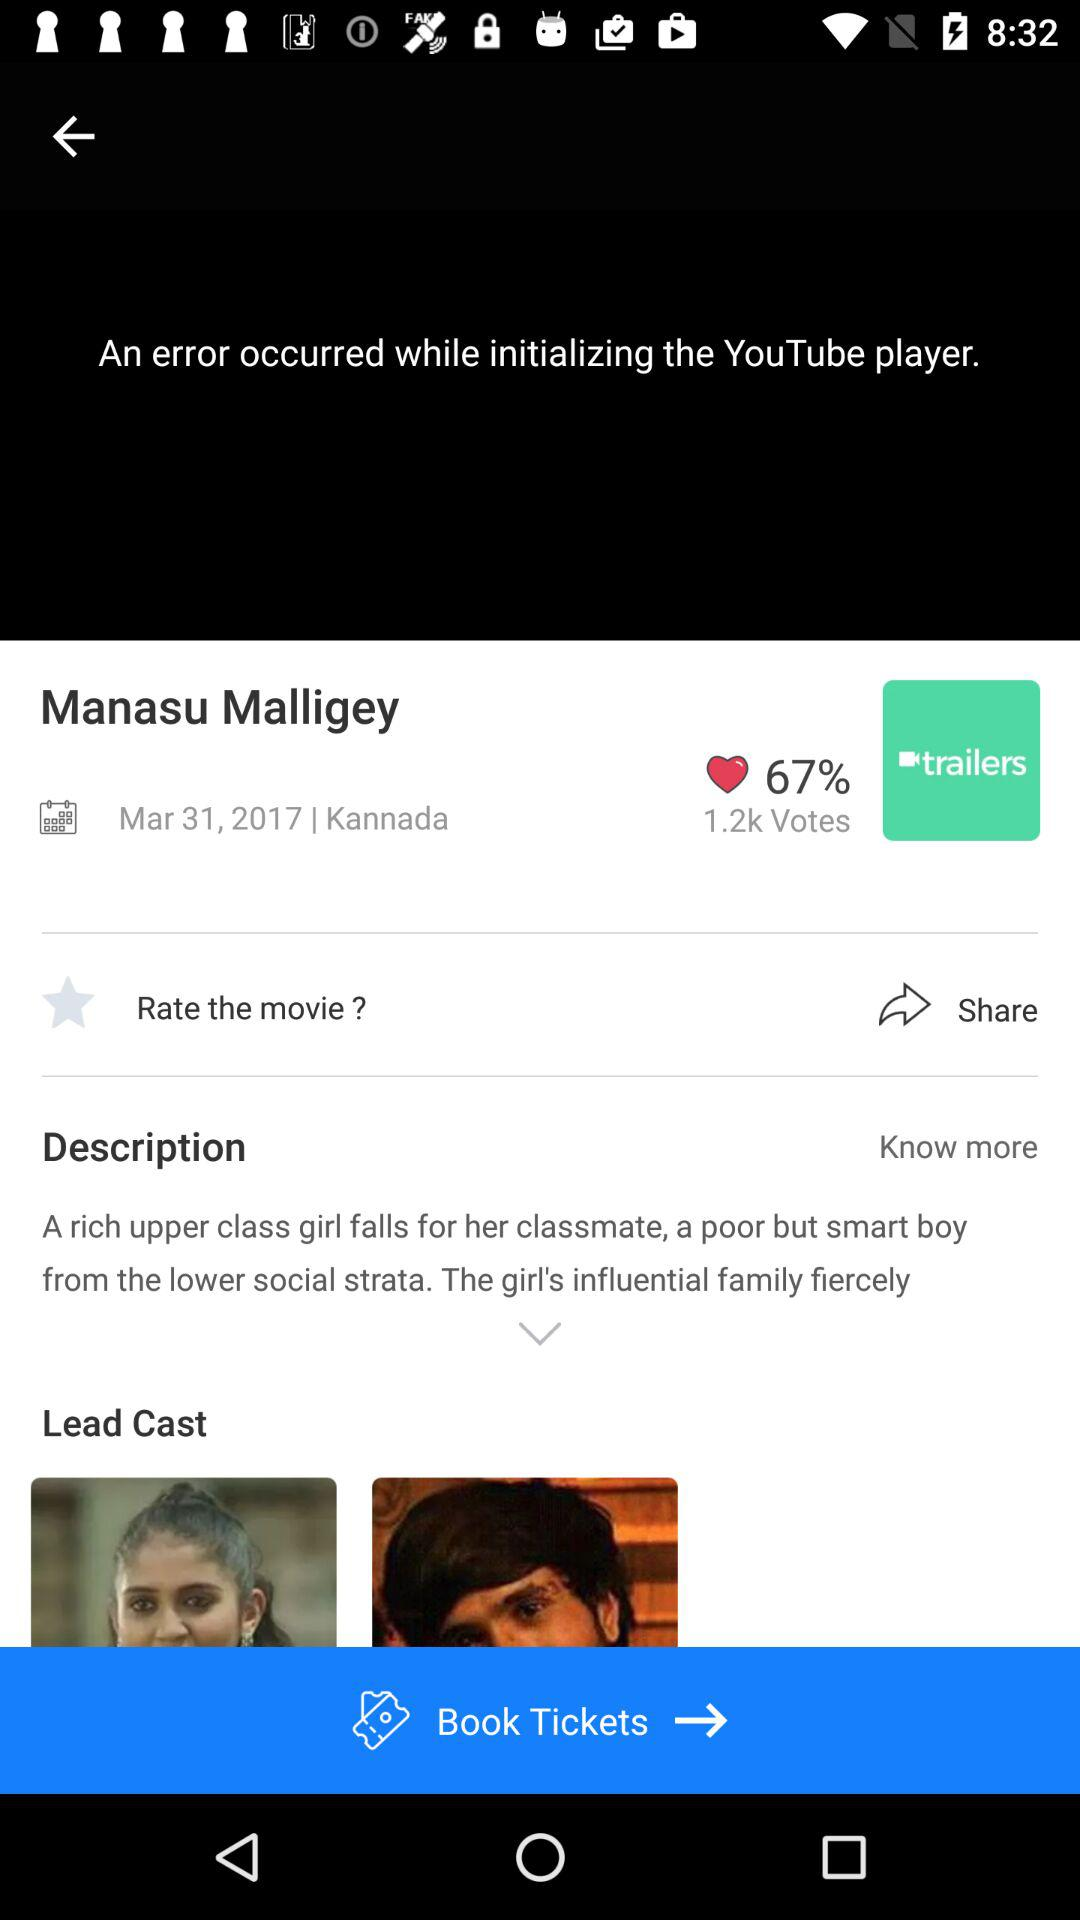What is the percentage of likes? The percentage of likes is 67. 